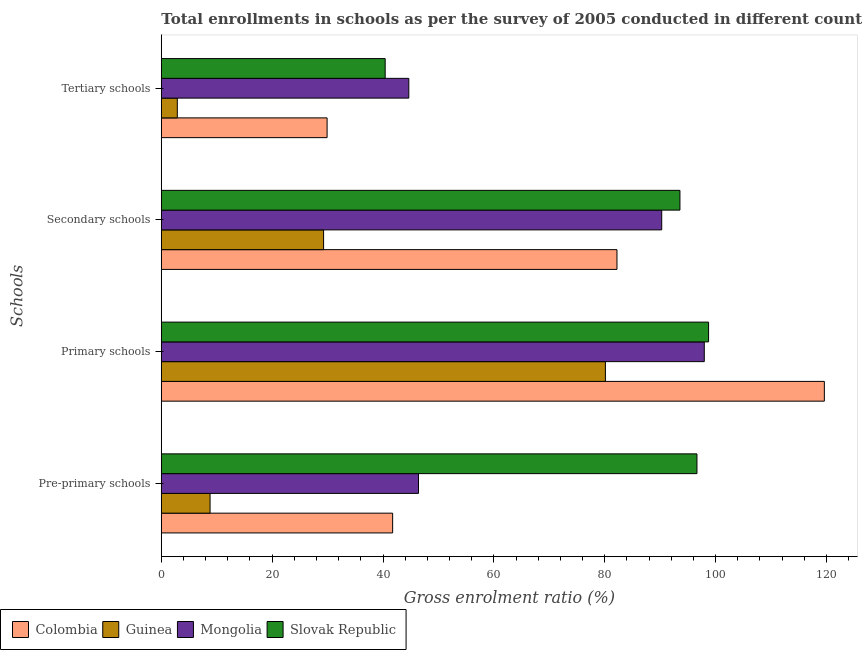How many different coloured bars are there?
Make the answer very short. 4. Are the number of bars on each tick of the Y-axis equal?
Offer a terse response. Yes. How many bars are there on the 3rd tick from the top?
Provide a succinct answer. 4. What is the label of the 4th group of bars from the top?
Ensure brevity in your answer.  Pre-primary schools. What is the gross enrolment ratio in secondary schools in Guinea?
Provide a short and direct response. 29.28. Across all countries, what is the maximum gross enrolment ratio in secondary schools?
Offer a terse response. 93.58. Across all countries, what is the minimum gross enrolment ratio in tertiary schools?
Keep it short and to the point. 2.89. In which country was the gross enrolment ratio in tertiary schools maximum?
Your answer should be compact. Mongolia. In which country was the gross enrolment ratio in pre-primary schools minimum?
Ensure brevity in your answer.  Guinea. What is the total gross enrolment ratio in pre-primary schools in the graph?
Keep it short and to the point. 193.58. What is the difference between the gross enrolment ratio in tertiary schools in Mongolia and that in Guinea?
Offer a very short reply. 41.77. What is the difference between the gross enrolment ratio in primary schools in Slovak Republic and the gross enrolment ratio in pre-primary schools in Colombia?
Make the answer very short. 57.01. What is the average gross enrolment ratio in secondary schools per country?
Your answer should be very brief. 73.84. What is the difference between the gross enrolment ratio in secondary schools and gross enrolment ratio in pre-primary schools in Colombia?
Make the answer very short. 40.48. In how many countries, is the gross enrolment ratio in primary schools greater than 96 %?
Ensure brevity in your answer.  3. What is the ratio of the gross enrolment ratio in tertiary schools in Mongolia to that in Guinea?
Provide a short and direct response. 15.48. Is the difference between the gross enrolment ratio in primary schools in Slovak Republic and Colombia greater than the difference between the gross enrolment ratio in secondary schools in Slovak Republic and Colombia?
Provide a succinct answer. No. What is the difference between the highest and the second highest gross enrolment ratio in pre-primary schools?
Your answer should be very brief. 50.24. What is the difference between the highest and the lowest gross enrolment ratio in primary schools?
Keep it short and to the point. 39.5. In how many countries, is the gross enrolment ratio in pre-primary schools greater than the average gross enrolment ratio in pre-primary schools taken over all countries?
Your answer should be very brief. 1. What does the 3rd bar from the top in Secondary schools represents?
Offer a terse response. Guinea. What does the 2nd bar from the bottom in Pre-primary schools represents?
Your answer should be very brief. Guinea. Are all the bars in the graph horizontal?
Ensure brevity in your answer.  Yes. How many countries are there in the graph?
Ensure brevity in your answer.  4. Does the graph contain grids?
Keep it short and to the point. No. How many legend labels are there?
Offer a very short reply. 4. How are the legend labels stacked?
Provide a succinct answer. Horizontal. What is the title of the graph?
Offer a very short reply. Total enrollments in schools as per the survey of 2005 conducted in different countries. Does "Central African Republic" appear as one of the legend labels in the graph?
Offer a very short reply. No. What is the label or title of the X-axis?
Give a very brief answer. Gross enrolment ratio (%). What is the label or title of the Y-axis?
Your response must be concise. Schools. What is the Gross enrolment ratio (%) in Colombia in Pre-primary schools?
Your response must be concise. 41.74. What is the Gross enrolment ratio (%) in Guinea in Pre-primary schools?
Ensure brevity in your answer.  8.79. What is the Gross enrolment ratio (%) of Mongolia in Pre-primary schools?
Provide a succinct answer. 46.41. What is the Gross enrolment ratio (%) of Slovak Republic in Pre-primary schools?
Provide a succinct answer. 96.65. What is the Gross enrolment ratio (%) of Colombia in Primary schools?
Keep it short and to the point. 119.63. What is the Gross enrolment ratio (%) in Guinea in Primary schools?
Your answer should be very brief. 80.13. What is the Gross enrolment ratio (%) in Mongolia in Primary schools?
Keep it short and to the point. 97.97. What is the Gross enrolment ratio (%) in Slovak Republic in Primary schools?
Offer a very short reply. 98.75. What is the Gross enrolment ratio (%) in Colombia in Secondary schools?
Offer a terse response. 82.21. What is the Gross enrolment ratio (%) of Guinea in Secondary schools?
Your answer should be compact. 29.28. What is the Gross enrolment ratio (%) of Mongolia in Secondary schools?
Keep it short and to the point. 90.29. What is the Gross enrolment ratio (%) of Slovak Republic in Secondary schools?
Your response must be concise. 93.58. What is the Gross enrolment ratio (%) in Colombia in Tertiary schools?
Provide a short and direct response. 29.91. What is the Gross enrolment ratio (%) of Guinea in Tertiary schools?
Give a very brief answer. 2.89. What is the Gross enrolment ratio (%) in Mongolia in Tertiary schools?
Your answer should be very brief. 44.66. What is the Gross enrolment ratio (%) of Slovak Republic in Tertiary schools?
Provide a succinct answer. 40.39. Across all Schools, what is the maximum Gross enrolment ratio (%) of Colombia?
Offer a terse response. 119.63. Across all Schools, what is the maximum Gross enrolment ratio (%) in Guinea?
Keep it short and to the point. 80.13. Across all Schools, what is the maximum Gross enrolment ratio (%) in Mongolia?
Offer a very short reply. 97.97. Across all Schools, what is the maximum Gross enrolment ratio (%) in Slovak Republic?
Your answer should be compact. 98.75. Across all Schools, what is the minimum Gross enrolment ratio (%) in Colombia?
Your answer should be compact. 29.91. Across all Schools, what is the minimum Gross enrolment ratio (%) of Guinea?
Give a very brief answer. 2.89. Across all Schools, what is the minimum Gross enrolment ratio (%) in Mongolia?
Your answer should be very brief. 44.66. Across all Schools, what is the minimum Gross enrolment ratio (%) in Slovak Republic?
Keep it short and to the point. 40.39. What is the total Gross enrolment ratio (%) of Colombia in the graph?
Your answer should be compact. 273.5. What is the total Gross enrolment ratio (%) of Guinea in the graph?
Your answer should be very brief. 121.09. What is the total Gross enrolment ratio (%) in Mongolia in the graph?
Give a very brief answer. 279.32. What is the total Gross enrolment ratio (%) in Slovak Republic in the graph?
Offer a very short reply. 329.36. What is the difference between the Gross enrolment ratio (%) of Colombia in Pre-primary schools and that in Primary schools?
Your response must be concise. -77.89. What is the difference between the Gross enrolment ratio (%) in Guinea in Pre-primary schools and that in Primary schools?
Give a very brief answer. -71.33. What is the difference between the Gross enrolment ratio (%) in Mongolia in Pre-primary schools and that in Primary schools?
Your answer should be very brief. -51.56. What is the difference between the Gross enrolment ratio (%) of Slovak Republic in Pre-primary schools and that in Primary schools?
Your answer should be very brief. -2.1. What is the difference between the Gross enrolment ratio (%) in Colombia in Pre-primary schools and that in Secondary schools?
Give a very brief answer. -40.48. What is the difference between the Gross enrolment ratio (%) of Guinea in Pre-primary schools and that in Secondary schools?
Provide a succinct answer. -20.49. What is the difference between the Gross enrolment ratio (%) in Mongolia in Pre-primary schools and that in Secondary schools?
Ensure brevity in your answer.  -43.89. What is the difference between the Gross enrolment ratio (%) of Slovak Republic in Pre-primary schools and that in Secondary schools?
Make the answer very short. 3.07. What is the difference between the Gross enrolment ratio (%) of Colombia in Pre-primary schools and that in Tertiary schools?
Offer a very short reply. 11.83. What is the difference between the Gross enrolment ratio (%) in Guinea in Pre-primary schools and that in Tertiary schools?
Provide a short and direct response. 5.91. What is the difference between the Gross enrolment ratio (%) of Mongolia in Pre-primary schools and that in Tertiary schools?
Your response must be concise. 1.75. What is the difference between the Gross enrolment ratio (%) in Slovak Republic in Pre-primary schools and that in Tertiary schools?
Provide a succinct answer. 56.26. What is the difference between the Gross enrolment ratio (%) in Colombia in Primary schools and that in Secondary schools?
Your answer should be very brief. 37.42. What is the difference between the Gross enrolment ratio (%) in Guinea in Primary schools and that in Secondary schools?
Keep it short and to the point. 50.85. What is the difference between the Gross enrolment ratio (%) in Mongolia in Primary schools and that in Secondary schools?
Offer a terse response. 7.68. What is the difference between the Gross enrolment ratio (%) of Slovak Republic in Primary schools and that in Secondary schools?
Provide a succinct answer. 5.17. What is the difference between the Gross enrolment ratio (%) in Colombia in Primary schools and that in Tertiary schools?
Ensure brevity in your answer.  89.72. What is the difference between the Gross enrolment ratio (%) of Guinea in Primary schools and that in Tertiary schools?
Ensure brevity in your answer.  77.24. What is the difference between the Gross enrolment ratio (%) in Mongolia in Primary schools and that in Tertiary schools?
Your answer should be compact. 53.31. What is the difference between the Gross enrolment ratio (%) of Slovak Republic in Primary schools and that in Tertiary schools?
Give a very brief answer. 58.35. What is the difference between the Gross enrolment ratio (%) in Colombia in Secondary schools and that in Tertiary schools?
Keep it short and to the point. 52.3. What is the difference between the Gross enrolment ratio (%) of Guinea in Secondary schools and that in Tertiary schools?
Ensure brevity in your answer.  26.4. What is the difference between the Gross enrolment ratio (%) in Mongolia in Secondary schools and that in Tertiary schools?
Your answer should be compact. 45.63. What is the difference between the Gross enrolment ratio (%) of Slovak Republic in Secondary schools and that in Tertiary schools?
Give a very brief answer. 53.19. What is the difference between the Gross enrolment ratio (%) of Colombia in Pre-primary schools and the Gross enrolment ratio (%) of Guinea in Primary schools?
Offer a very short reply. -38.39. What is the difference between the Gross enrolment ratio (%) of Colombia in Pre-primary schools and the Gross enrolment ratio (%) of Mongolia in Primary schools?
Give a very brief answer. -56.23. What is the difference between the Gross enrolment ratio (%) of Colombia in Pre-primary schools and the Gross enrolment ratio (%) of Slovak Republic in Primary schools?
Make the answer very short. -57.01. What is the difference between the Gross enrolment ratio (%) in Guinea in Pre-primary schools and the Gross enrolment ratio (%) in Mongolia in Primary schools?
Offer a very short reply. -89.18. What is the difference between the Gross enrolment ratio (%) of Guinea in Pre-primary schools and the Gross enrolment ratio (%) of Slovak Republic in Primary schools?
Make the answer very short. -89.95. What is the difference between the Gross enrolment ratio (%) of Mongolia in Pre-primary schools and the Gross enrolment ratio (%) of Slovak Republic in Primary schools?
Provide a succinct answer. -52.34. What is the difference between the Gross enrolment ratio (%) of Colombia in Pre-primary schools and the Gross enrolment ratio (%) of Guinea in Secondary schools?
Give a very brief answer. 12.46. What is the difference between the Gross enrolment ratio (%) in Colombia in Pre-primary schools and the Gross enrolment ratio (%) in Mongolia in Secondary schools?
Your answer should be compact. -48.55. What is the difference between the Gross enrolment ratio (%) of Colombia in Pre-primary schools and the Gross enrolment ratio (%) of Slovak Republic in Secondary schools?
Offer a very short reply. -51.84. What is the difference between the Gross enrolment ratio (%) of Guinea in Pre-primary schools and the Gross enrolment ratio (%) of Mongolia in Secondary schools?
Your answer should be compact. -81.5. What is the difference between the Gross enrolment ratio (%) of Guinea in Pre-primary schools and the Gross enrolment ratio (%) of Slovak Republic in Secondary schools?
Provide a short and direct response. -84.78. What is the difference between the Gross enrolment ratio (%) in Mongolia in Pre-primary schools and the Gross enrolment ratio (%) in Slovak Republic in Secondary schools?
Give a very brief answer. -47.17. What is the difference between the Gross enrolment ratio (%) in Colombia in Pre-primary schools and the Gross enrolment ratio (%) in Guinea in Tertiary schools?
Your response must be concise. 38.85. What is the difference between the Gross enrolment ratio (%) of Colombia in Pre-primary schools and the Gross enrolment ratio (%) of Mongolia in Tertiary schools?
Your answer should be very brief. -2.92. What is the difference between the Gross enrolment ratio (%) of Colombia in Pre-primary schools and the Gross enrolment ratio (%) of Slovak Republic in Tertiary schools?
Offer a very short reply. 1.35. What is the difference between the Gross enrolment ratio (%) in Guinea in Pre-primary schools and the Gross enrolment ratio (%) in Mongolia in Tertiary schools?
Your answer should be compact. -35.86. What is the difference between the Gross enrolment ratio (%) of Guinea in Pre-primary schools and the Gross enrolment ratio (%) of Slovak Republic in Tertiary schools?
Make the answer very short. -31.6. What is the difference between the Gross enrolment ratio (%) of Mongolia in Pre-primary schools and the Gross enrolment ratio (%) of Slovak Republic in Tertiary schools?
Offer a very short reply. 6.01. What is the difference between the Gross enrolment ratio (%) in Colombia in Primary schools and the Gross enrolment ratio (%) in Guinea in Secondary schools?
Make the answer very short. 90.35. What is the difference between the Gross enrolment ratio (%) in Colombia in Primary schools and the Gross enrolment ratio (%) in Mongolia in Secondary schools?
Give a very brief answer. 29.34. What is the difference between the Gross enrolment ratio (%) in Colombia in Primary schools and the Gross enrolment ratio (%) in Slovak Republic in Secondary schools?
Your answer should be very brief. 26.06. What is the difference between the Gross enrolment ratio (%) in Guinea in Primary schools and the Gross enrolment ratio (%) in Mongolia in Secondary schools?
Give a very brief answer. -10.16. What is the difference between the Gross enrolment ratio (%) in Guinea in Primary schools and the Gross enrolment ratio (%) in Slovak Republic in Secondary schools?
Offer a terse response. -13.45. What is the difference between the Gross enrolment ratio (%) of Mongolia in Primary schools and the Gross enrolment ratio (%) of Slovak Republic in Secondary schools?
Give a very brief answer. 4.39. What is the difference between the Gross enrolment ratio (%) in Colombia in Primary schools and the Gross enrolment ratio (%) in Guinea in Tertiary schools?
Give a very brief answer. 116.75. What is the difference between the Gross enrolment ratio (%) of Colombia in Primary schools and the Gross enrolment ratio (%) of Mongolia in Tertiary schools?
Offer a very short reply. 74.98. What is the difference between the Gross enrolment ratio (%) in Colombia in Primary schools and the Gross enrolment ratio (%) in Slovak Republic in Tertiary schools?
Make the answer very short. 79.24. What is the difference between the Gross enrolment ratio (%) of Guinea in Primary schools and the Gross enrolment ratio (%) of Mongolia in Tertiary schools?
Provide a succinct answer. 35.47. What is the difference between the Gross enrolment ratio (%) of Guinea in Primary schools and the Gross enrolment ratio (%) of Slovak Republic in Tertiary schools?
Your response must be concise. 39.74. What is the difference between the Gross enrolment ratio (%) of Mongolia in Primary schools and the Gross enrolment ratio (%) of Slovak Republic in Tertiary schools?
Your response must be concise. 57.58. What is the difference between the Gross enrolment ratio (%) of Colombia in Secondary schools and the Gross enrolment ratio (%) of Guinea in Tertiary schools?
Your answer should be compact. 79.33. What is the difference between the Gross enrolment ratio (%) in Colombia in Secondary schools and the Gross enrolment ratio (%) in Mongolia in Tertiary schools?
Your response must be concise. 37.56. What is the difference between the Gross enrolment ratio (%) in Colombia in Secondary schools and the Gross enrolment ratio (%) in Slovak Republic in Tertiary schools?
Ensure brevity in your answer.  41.82. What is the difference between the Gross enrolment ratio (%) in Guinea in Secondary schools and the Gross enrolment ratio (%) in Mongolia in Tertiary schools?
Offer a terse response. -15.38. What is the difference between the Gross enrolment ratio (%) in Guinea in Secondary schools and the Gross enrolment ratio (%) in Slovak Republic in Tertiary schools?
Provide a short and direct response. -11.11. What is the difference between the Gross enrolment ratio (%) in Mongolia in Secondary schools and the Gross enrolment ratio (%) in Slovak Republic in Tertiary schools?
Ensure brevity in your answer.  49.9. What is the average Gross enrolment ratio (%) in Colombia per Schools?
Make the answer very short. 68.37. What is the average Gross enrolment ratio (%) of Guinea per Schools?
Make the answer very short. 30.27. What is the average Gross enrolment ratio (%) in Mongolia per Schools?
Your answer should be compact. 69.83. What is the average Gross enrolment ratio (%) of Slovak Republic per Schools?
Offer a very short reply. 82.34. What is the difference between the Gross enrolment ratio (%) in Colombia and Gross enrolment ratio (%) in Guinea in Pre-primary schools?
Offer a very short reply. 32.94. What is the difference between the Gross enrolment ratio (%) in Colombia and Gross enrolment ratio (%) in Mongolia in Pre-primary schools?
Your answer should be compact. -4.67. What is the difference between the Gross enrolment ratio (%) of Colombia and Gross enrolment ratio (%) of Slovak Republic in Pre-primary schools?
Give a very brief answer. -54.91. What is the difference between the Gross enrolment ratio (%) in Guinea and Gross enrolment ratio (%) in Mongolia in Pre-primary schools?
Your response must be concise. -37.61. What is the difference between the Gross enrolment ratio (%) of Guinea and Gross enrolment ratio (%) of Slovak Republic in Pre-primary schools?
Your answer should be compact. -87.85. What is the difference between the Gross enrolment ratio (%) in Mongolia and Gross enrolment ratio (%) in Slovak Republic in Pre-primary schools?
Offer a terse response. -50.24. What is the difference between the Gross enrolment ratio (%) of Colombia and Gross enrolment ratio (%) of Guinea in Primary schools?
Offer a terse response. 39.5. What is the difference between the Gross enrolment ratio (%) of Colombia and Gross enrolment ratio (%) of Mongolia in Primary schools?
Keep it short and to the point. 21.66. What is the difference between the Gross enrolment ratio (%) of Colombia and Gross enrolment ratio (%) of Slovak Republic in Primary schools?
Provide a succinct answer. 20.89. What is the difference between the Gross enrolment ratio (%) of Guinea and Gross enrolment ratio (%) of Mongolia in Primary schools?
Offer a terse response. -17.84. What is the difference between the Gross enrolment ratio (%) in Guinea and Gross enrolment ratio (%) in Slovak Republic in Primary schools?
Provide a short and direct response. -18.62. What is the difference between the Gross enrolment ratio (%) in Mongolia and Gross enrolment ratio (%) in Slovak Republic in Primary schools?
Provide a succinct answer. -0.78. What is the difference between the Gross enrolment ratio (%) in Colombia and Gross enrolment ratio (%) in Guinea in Secondary schools?
Your answer should be compact. 52.93. What is the difference between the Gross enrolment ratio (%) of Colombia and Gross enrolment ratio (%) of Mongolia in Secondary schools?
Give a very brief answer. -8.08. What is the difference between the Gross enrolment ratio (%) in Colombia and Gross enrolment ratio (%) in Slovak Republic in Secondary schools?
Your answer should be very brief. -11.36. What is the difference between the Gross enrolment ratio (%) in Guinea and Gross enrolment ratio (%) in Mongolia in Secondary schools?
Your response must be concise. -61.01. What is the difference between the Gross enrolment ratio (%) in Guinea and Gross enrolment ratio (%) in Slovak Republic in Secondary schools?
Make the answer very short. -64.3. What is the difference between the Gross enrolment ratio (%) of Mongolia and Gross enrolment ratio (%) of Slovak Republic in Secondary schools?
Keep it short and to the point. -3.29. What is the difference between the Gross enrolment ratio (%) in Colombia and Gross enrolment ratio (%) in Guinea in Tertiary schools?
Your answer should be very brief. 27.03. What is the difference between the Gross enrolment ratio (%) of Colombia and Gross enrolment ratio (%) of Mongolia in Tertiary schools?
Offer a very short reply. -14.75. What is the difference between the Gross enrolment ratio (%) of Colombia and Gross enrolment ratio (%) of Slovak Republic in Tertiary schools?
Make the answer very short. -10.48. What is the difference between the Gross enrolment ratio (%) of Guinea and Gross enrolment ratio (%) of Mongolia in Tertiary schools?
Your response must be concise. -41.77. What is the difference between the Gross enrolment ratio (%) in Guinea and Gross enrolment ratio (%) in Slovak Republic in Tertiary schools?
Give a very brief answer. -37.51. What is the difference between the Gross enrolment ratio (%) of Mongolia and Gross enrolment ratio (%) of Slovak Republic in Tertiary schools?
Your response must be concise. 4.27. What is the ratio of the Gross enrolment ratio (%) of Colombia in Pre-primary schools to that in Primary schools?
Give a very brief answer. 0.35. What is the ratio of the Gross enrolment ratio (%) in Guinea in Pre-primary schools to that in Primary schools?
Your response must be concise. 0.11. What is the ratio of the Gross enrolment ratio (%) in Mongolia in Pre-primary schools to that in Primary schools?
Make the answer very short. 0.47. What is the ratio of the Gross enrolment ratio (%) in Slovak Republic in Pre-primary schools to that in Primary schools?
Your answer should be very brief. 0.98. What is the ratio of the Gross enrolment ratio (%) in Colombia in Pre-primary schools to that in Secondary schools?
Your response must be concise. 0.51. What is the ratio of the Gross enrolment ratio (%) of Guinea in Pre-primary schools to that in Secondary schools?
Offer a terse response. 0.3. What is the ratio of the Gross enrolment ratio (%) in Mongolia in Pre-primary schools to that in Secondary schools?
Keep it short and to the point. 0.51. What is the ratio of the Gross enrolment ratio (%) in Slovak Republic in Pre-primary schools to that in Secondary schools?
Your response must be concise. 1.03. What is the ratio of the Gross enrolment ratio (%) in Colombia in Pre-primary schools to that in Tertiary schools?
Provide a succinct answer. 1.4. What is the ratio of the Gross enrolment ratio (%) in Guinea in Pre-primary schools to that in Tertiary schools?
Offer a very short reply. 3.05. What is the ratio of the Gross enrolment ratio (%) of Mongolia in Pre-primary schools to that in Tertiary schools?
Provide a short and direct response. 1.04. What is the ratio of the Gross enrolment ratio (%) of Slovak Republic in Pre-primary schools to that in Tertiary schools?
Give a very brief answer. 2.39. What is the ratio of the Gross enrolment ratio (%) of Colombia in Primary schools to that in Secondary schools?
Your answer should be compact. 1.46. What is the ratio of the Gross enrolment ratio (%) of Guinea in Primary schools to that in Secondary schools?
Make the answer very short. 2.74. What is the ratio of the Gross enrolment ratio (%) in Mongolia in Primary schools to that in Secondary schools?
Your answer should be compact. 1.08. What is the ratio of the Gross enrolment ratio (%) in Slovak Republic in Primary schools to that in Secondary schools?
Your response must be concise. 1.06. What is the ratio of the Gross enrolment ratio (%) of Colombia in Primary schools to that in Tertiary schools?
Keep it short and to the point. 4. What is the ratio of the Gross enrolment ratio (%) in Guinea in Primary schools to that in Tertiary schools?
Keep it short and to the point. 27.77. What is the ratio of the Gross enrolment ratio (%) in Mongolia in Primary schools to that in Tertiary schools?
Your answer should be compact. 2.19. What is the ratio of the Gross enrolment ratio (%) in Slovak Republic in Primary schools to that in Tertiary schools?
Provide a succinct answer. 2.44. What is the ratio of the Gross enrolment ratio (%) in Colombia in Secondary schools to that in Tertiary schools?
Your answer should be compact. 2.75. What is the ratio of the Gross enrolment ratio (%) in Guinea in Secondary schools to that in Tertiary schools?
Give a very brief answer. 10.15. What is the ratio of the Gross enrolment ratio (%) of Mongolia in Secondary schools to that in Tertiary schools?
Offer a terse response. 2.02. What is the ratio of the Gross enrolment ratio (%) in Slovak Republic in Secondary schools to that in Tertiary schools?
Ensure brevity in your answer.  2.32. What is the difference between the highest and the second highest Gross enrolment ratio (%) in Colombia?
Give a very brief answer. 37.42. What is the difference between the highest and the second highest Gross enrolment ratio (%) in Guinea?
Your answer should be compact. 50.85. What is the difference between the highest and the second highest Gross enrolment ratio (%) of Mongolia?
Keep it short and to the point. 7.68. What is the difference between the highest and the second highest Gross enrolment ratio (%) in Slovak Republic?
Keep it short and to the point. 2.1. What is the difference between the highest and the lowest Gross enrolment ratio (%) of Colombia?
Your answer should be very brief. 89.72. What is the difference between the highest and the lowest Gross enrolment ratio (%) in Guinea?
Provide a short and direct response. 77.24. What is the difference between the highest and the lowest Gross enrolment ratio (%) of Mongolia?
Give a very brief answer. 53.31. What is the difference between the highest and the lowest Gross enrolment ratio (%) in Slovak Republic?
Give a very brief answer. 58.35. 